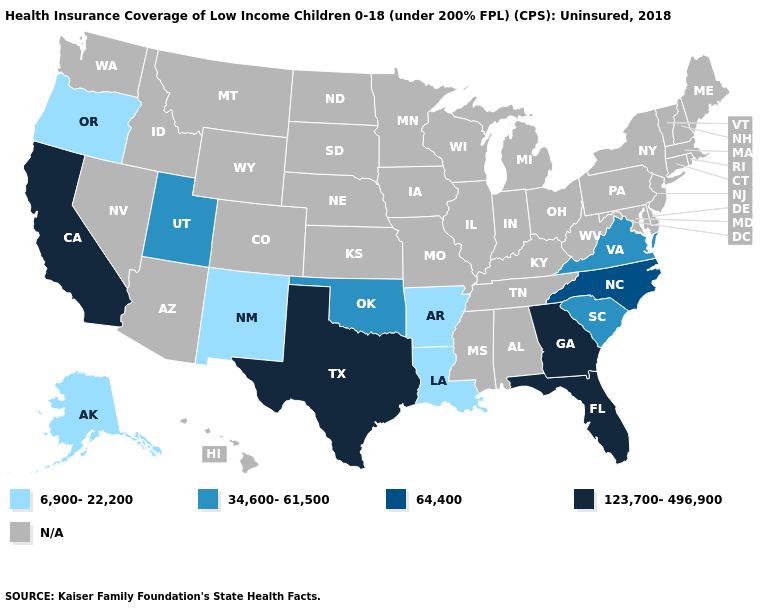Does Alaska have the highest value in the USA?
Short answer required. No. Which states have the lowest value in the USA?
Answer briefly. Alaska, Arkansas, Louisiana, New Mexico, Oregon. Which states have the highest value in the USA?
Write a very short answer. California, Florida, Georgia, Texas. Which states hav the highest value in the South?
Concise answer only. Florida, Georgia, Texas. What is the highest value in the USA?
Quick response, please. 123,700-496,900. Among the states that border Colorado , which have the highest value?
Short answer required. Oklahoma, Utah. What is the value of Florida?
Short answer required. 123,700-496,900. What is the lowest value in the West?
Be succinct. 6,900-22,200. Is the legend a continuous bar?
Give a very brief answer. No. What is the value of North Dakota?
Concise answer only. N/A. 